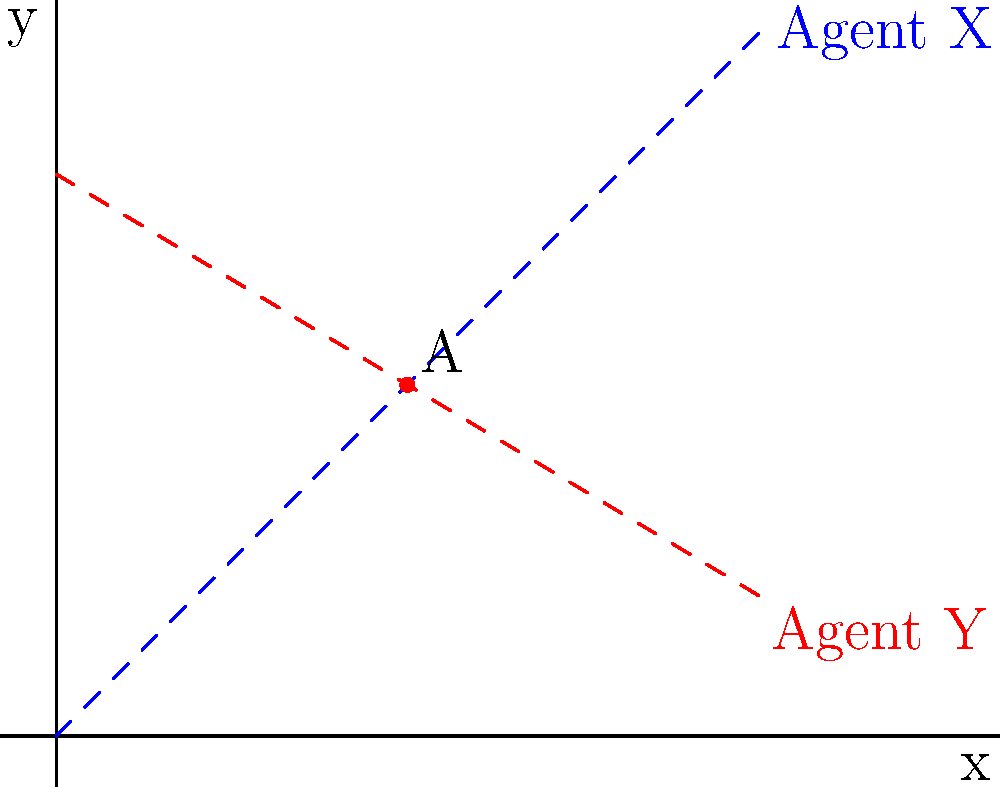Two undercover agents, X and Y, are moving along different paths in a high-risk area. Agent X's path is represented by the equation $y = x$, while Agent Y's path is given by $y = -\frac{3}{5}x + 4$. At what point (x, y) do their paths intersect, potentially allowing for a covert information exchange? To find the intersection point of the two paths, we need to solve the system of equations:

1) Agent X's path: $y = x$
2) Agent Y's path: $y = -\frac{3}{5}x + 4$

Step 1: Set the equations equal to each other since they intersect at a point where y is the same for both.
$x = -\frac{3}{5}x + 4$

Step 2: Solve for x
$x + \frac{3}{5}x = 4$
$\frac{8}{5}x = 4$
$x = \frac{20}{8} = 2.5$

Step 3: Find y by substituting x into either equation. Let's use Agent X's equation:
$y = x = 2.5$

Therefore, the intersection point is (2.5, 2.5).
Answer: (2.5, 2.5) 